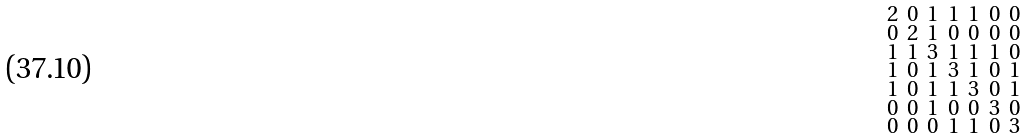<formula> <loc_0><loc_0><loc_500><loc_500>\begin{smallmatrix} 2 & 0 & 1 & 1 & 1 & 0 & 0 \\ 0 & 2 & 1 & 0 & 0 & 0 & 0 \\ 1 & 1 & 3 & 1 & 1 & 1 & 0 \\ 1 & 0 & 1 & 3 & 1 & 0 & 1 \\ 1 & 0 & 1 & 1 & 3 & 0 & 1 \\ 0 & 0 & 1 & 0 & 0 & 3 & 0 \\ 0 & 0 & 0 & 1 & 1 & 0 & 3 \end{smallmatrix}</formula> 